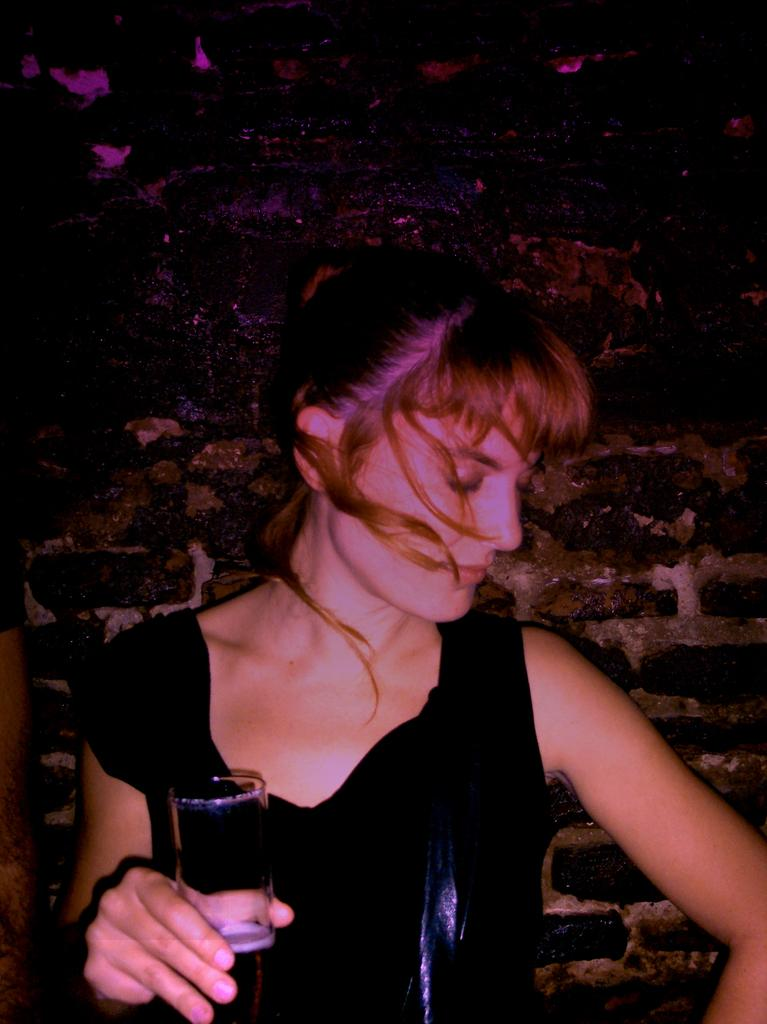Who is present in the image? There is a woman in the image. What is the woman doing in the image? The woman is standing in the image. What is the woman wearing in the image? The woman is wearing a black dress in the image. What object is the woman holding in the image? The woman is holding a glass in the image. What can be seen in the background of the image? There is a black wall in the background of the image. How many pies are on the table in the image? There is no table or pies present in the image; it features a woman standing in front of a black wall. 